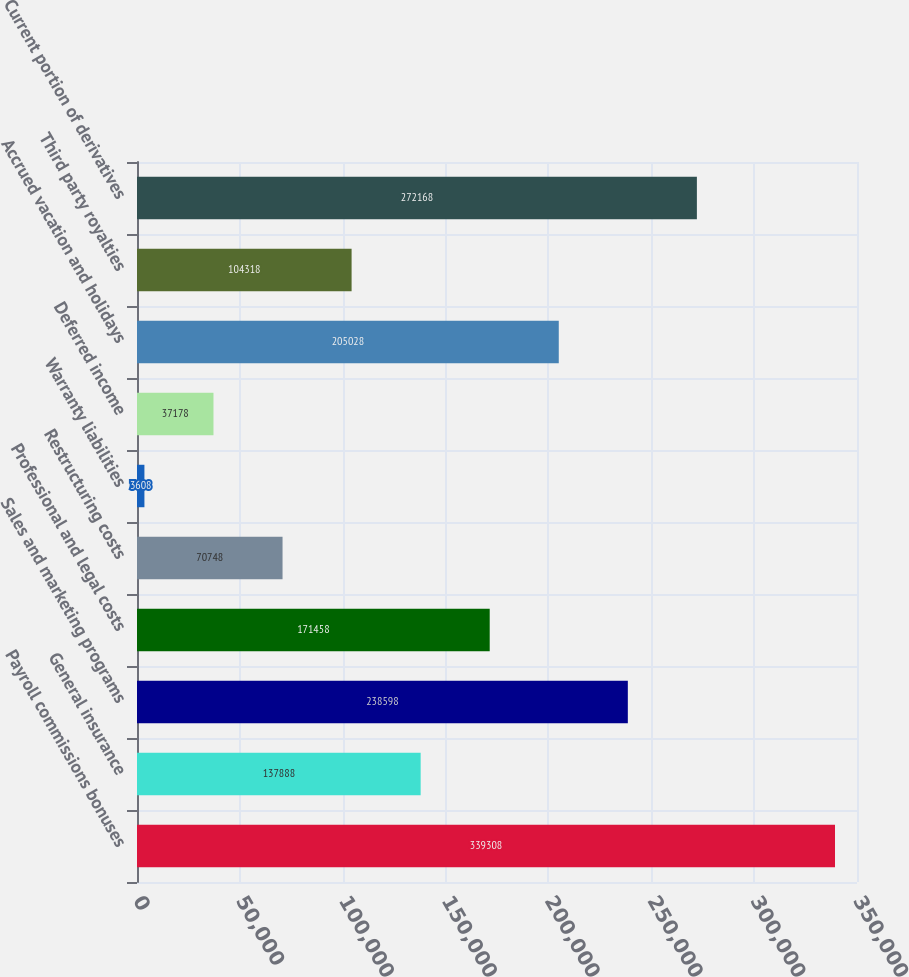Convert chart. <chart><loc_0><loc_0><loc_500><loc_500><bar_chart><fcel>Payroll commissions bonuses<fcel>General insurance<fcel>Sales and marketing programs<fcel>Professional and legal costs<fcel>Restructuring costs<fcel>Warranty liabilities<fcel>Deferred income<fcel>Accrued vacation and holidays<fcel>Third party royalties<fcel>Current portion of derivatives<nl><fcel>339308<fcel>137888<fcel>238598<fcel>171458<fcel>70748<fcel>3608<fcel>37178<fcel>205028<fcel>104318<fcel>272168<nl></chart> 